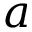<formula> <loc_0><loc_0><loc_500><loc_500>a</formula> 